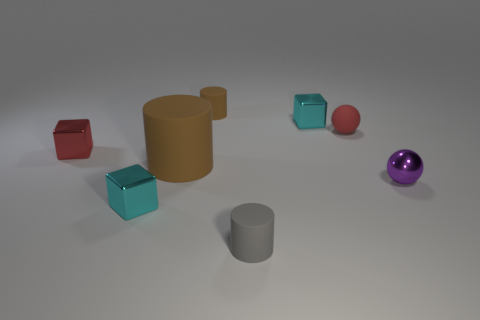How many small gray cylinders are on the left side of the big cylinder?
Keep it short and to the point. 0. What color is the tiny metal cube that is in front of the tiny red metallic cube that is in front of the cyan cube that is behind the purple ball?
Keep it short and to the point. Cyan. There is a cube behind the small rubber ball; is its color the same as the metallic thing that is in front of the tiny purple shiny thing?
Make the answer very short. Yes. There is a tiny cyan object behind the thing to the right of the tiny red rubber sphere; what is its shape?
Offer a terse response. Cube. Are there any cyan metallic cylinders that have the same size as the red shiny block?
Give a very brief answer. No. What number of tiny red metallic things have the same shape as the small brown object?
Offer a terse response. 0. Is the number of small gray matte cylinders that are on the left side of the small brown rubber cylinder the same as the number of cubes that are left of the small gray thing?
Your response must be concise. No. Are there any large cyan rubber spheres?
Offer a very short reply. No. There is a brown rubber cylinder in front of the small cyan cube right of the small metallic object that is in front of the purple object; what size is it?
Offer a terse response. Large. What shape is the gray thing that is the same size as the shiny ball?
Provide a short and direct response. Cylinder. 